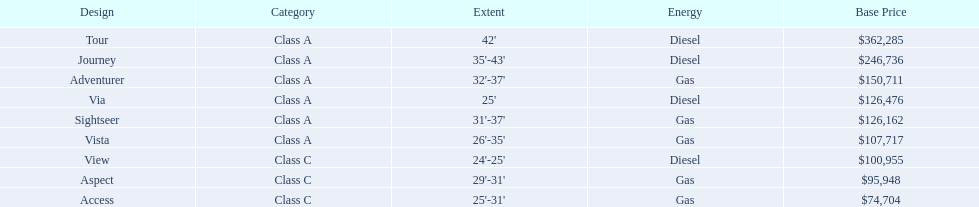Which model has the lowest starting price? Access. Which model has the second most highest starting price? Journey. Which model has the highest price in the winnebago industry? Tour. 